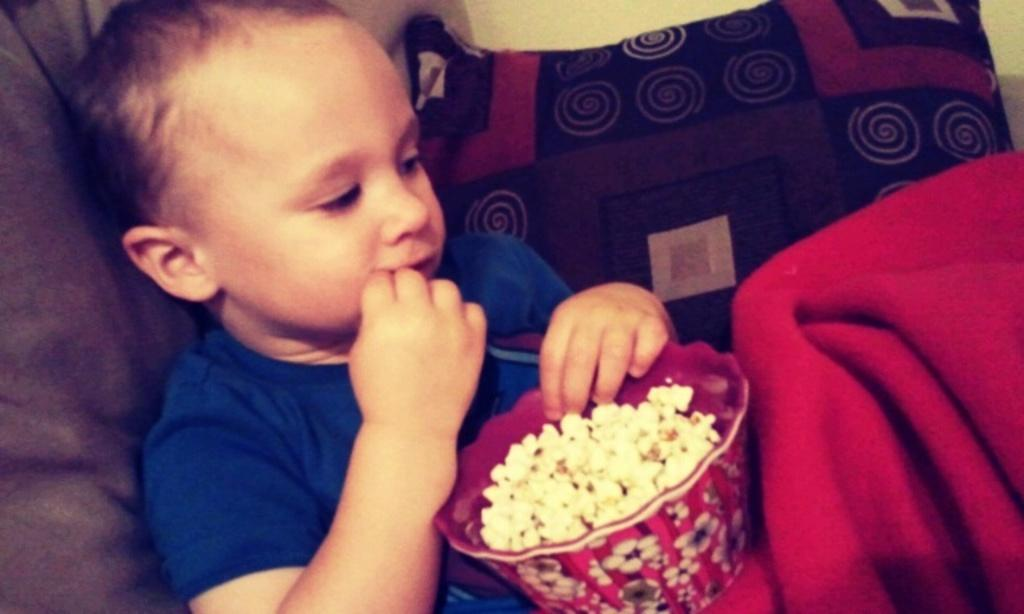Who is the main subject in the image? There is a child in the image. What is the child doing in the image? The child is sitting and eating popcorn. What is the source of the popcorn in the image? There is a bowl of popcorn in front of the child. What is beside the child in the image? There is a cushion beside the child. How much money is the child holding in the image? There is no indication of money in the image; the child is eating popcorn from a bowl. 